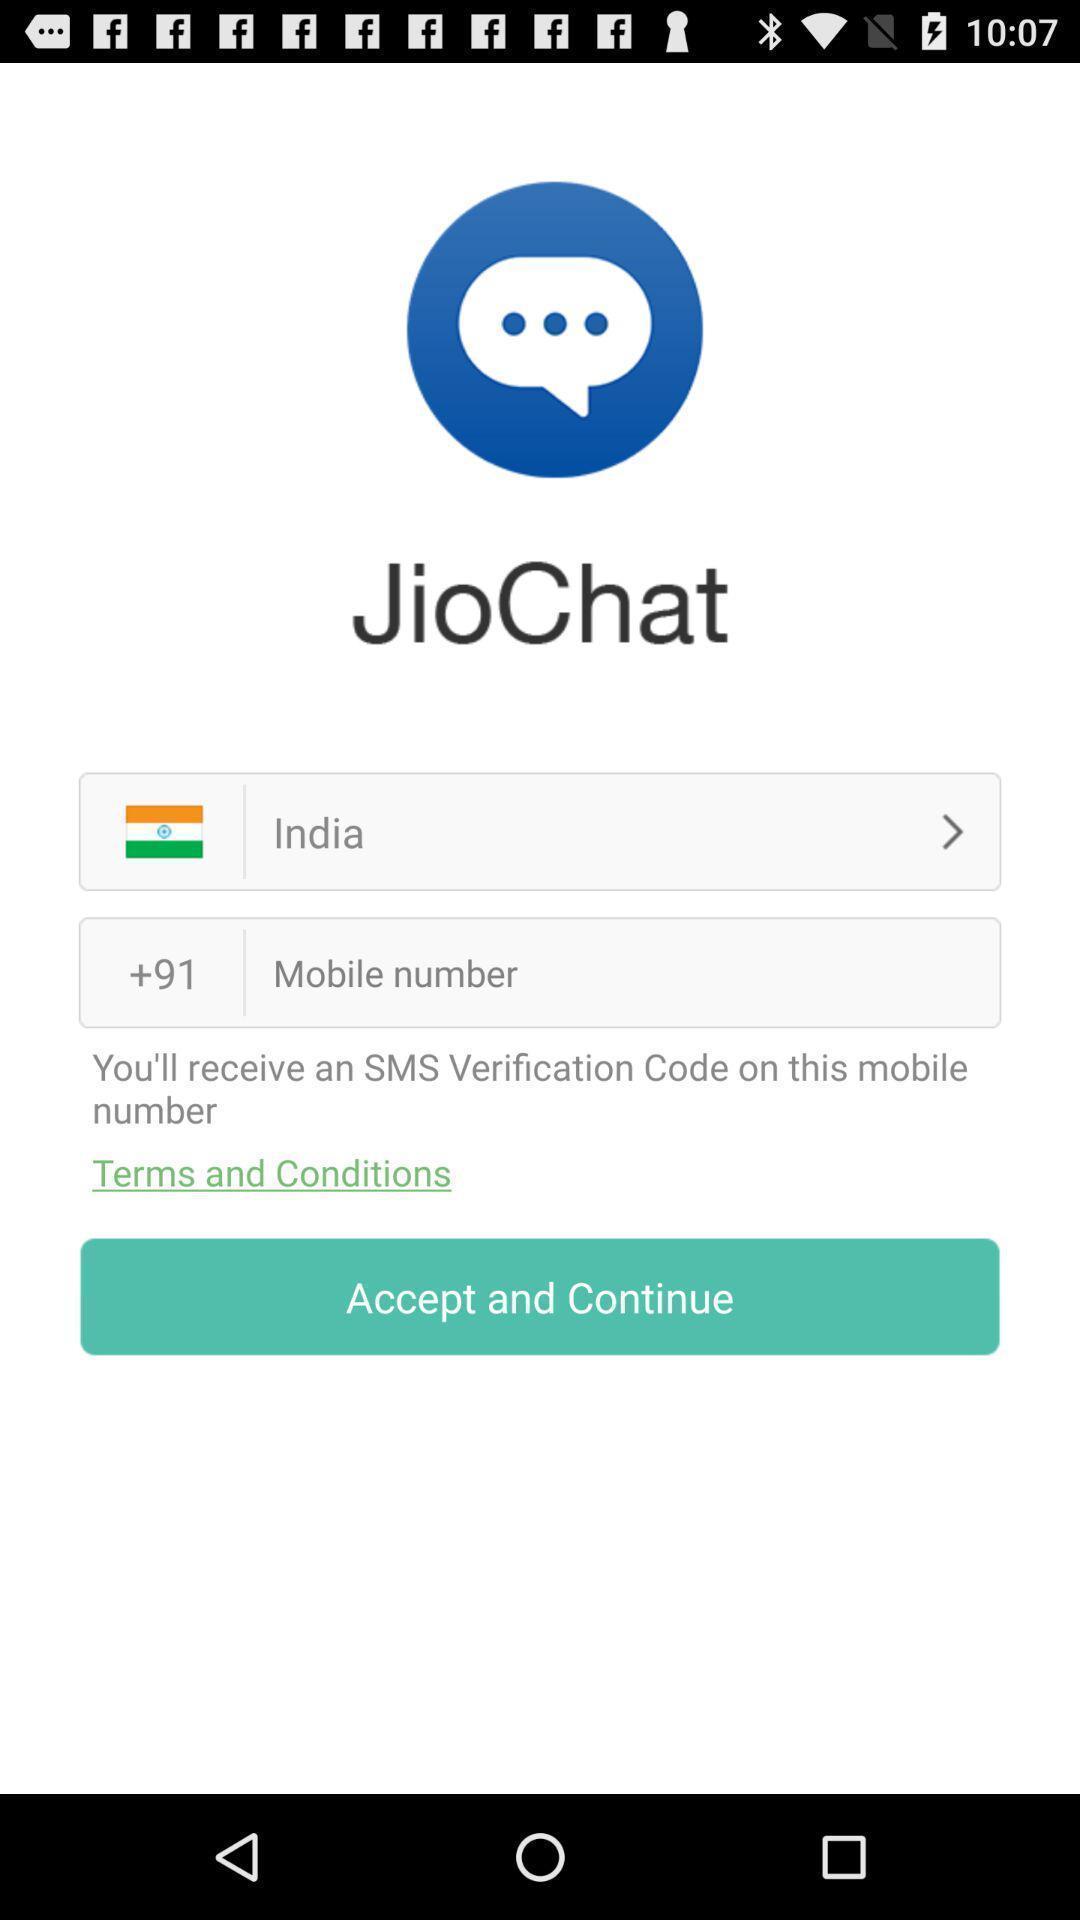What details can you identify in this image? Screen showing verification page. 